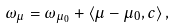Convert formula to latex. <formula><loc_0><loc_0><loc_500><loc_500>\omega _ { \mu } = \omega _ { \mu _ { 0 } } + \langle \mu - \mu _ { 0 } , c \rangle \, ,</formula> 